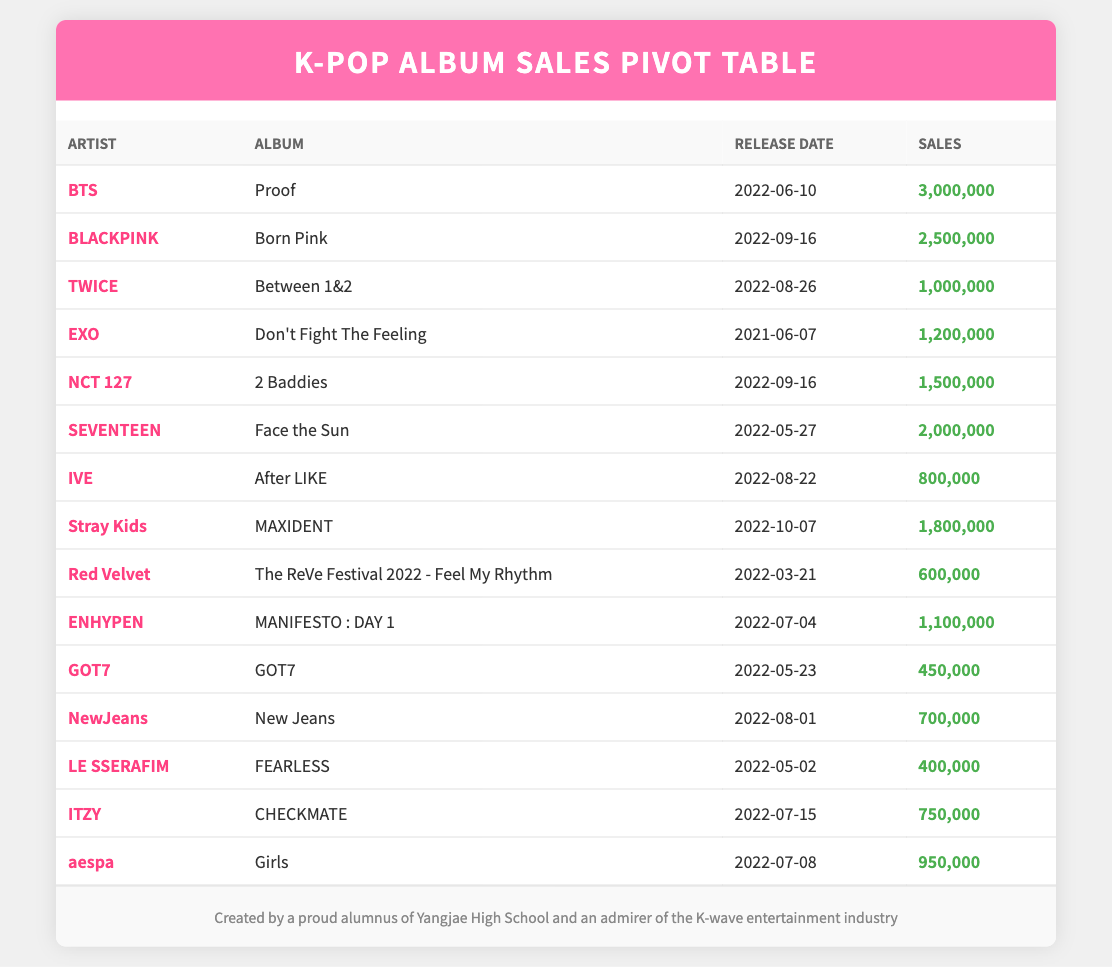What is the total sales for BTS's album "Proof"? BTS's album "Proof," released on 2022-06-10, has reported sales of 3,000,000. Therefore, the total sales are 3,000,000.
Answer: 3,000,000 Which artist has the lowest album sales, and what is the sales figure? The artist with the lowest album sales is GOT7, with their album "GOT7" having sales of 450,000.
Answer: GOT7, 450,000 How many albums were released by artists in September 2022, and what are their sales figures? Two albums were released in September 2022: BLACKPINK's "Born Pink" with sales of 2,500,000 and NCT 127's "2 Baddies" with sales of 1,500,000. Therefore, there are 2 albums with a total sales of 4,000,000.
Answer: 2 albums, 4,000,000 Is there an album by EXO with sales greater than 1 million? EXO's album "Don't Fight The Feeling" has sales of 1,200,000, which is greater than 1 million. Therefore, the answer is yes.
Answer: Yes What is the average album sales of albums released in 2022? To find the average, sum the sales of all albums released in 2022: 3,000,000 (BTS) + 2,500,000 (BLACKPINK) + 1,000,000 (TWICE) + 2,000,000 (SEVENTEEN) + 1,500,000 (NCT 127) + 800,000 (IVE) + 1,800,000 (Stray Kids) + 600,000 (Red Velvet) + 1,100,000 (ENHYPEN) + 450,000 (GOT7) + 700,000 (NewJeans) + 400,000 (LE SSERAFIM) + 750,000 (ITZY) + 950,000 (aespa) = 16,300,000. There are 14 albums, so the average is 16,300,000 / 14 = 1,161,429 (approximately).
Answer: 1,161,429 What is the sales difference between SEVENTEEN's "Face the Sun" and TWICE's "Between 1&2"? SEVENTEEN's album "Face the Sun" has sales of 2,000,000, while TWICE's "Between 1&2" has sales of 1,000,000. The difference in sales is 2,000,000 - 1,000,000 = 1,000,000.
Answer: 1,000,000 